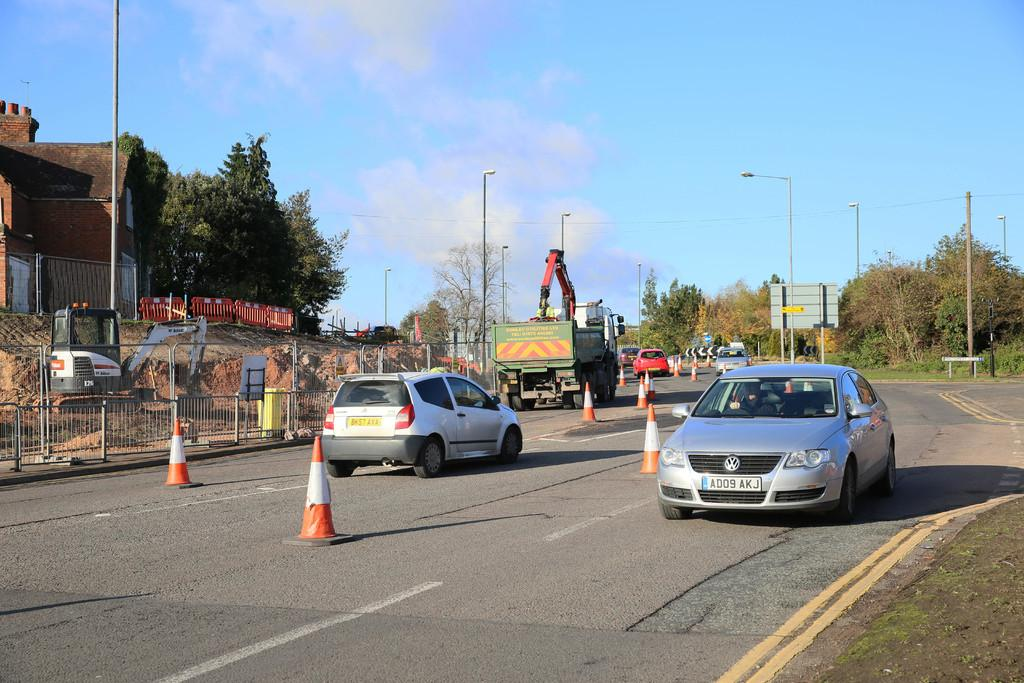What is the main feature of the picture? There is a road in the picture. What is happening on the road? There are vehicles moving on the road. What type of natural elements can be seen in the picture? There are trees in the picture. What type of man-made structures are visible in the picture? There are buildings in the picture. How would you describe the weather based on the image? The sky is clear, suggesting good weather. What type of tin can be seen being transported on the road? There is no tin visible in the image, nor is there any indication of transportation of tin. 